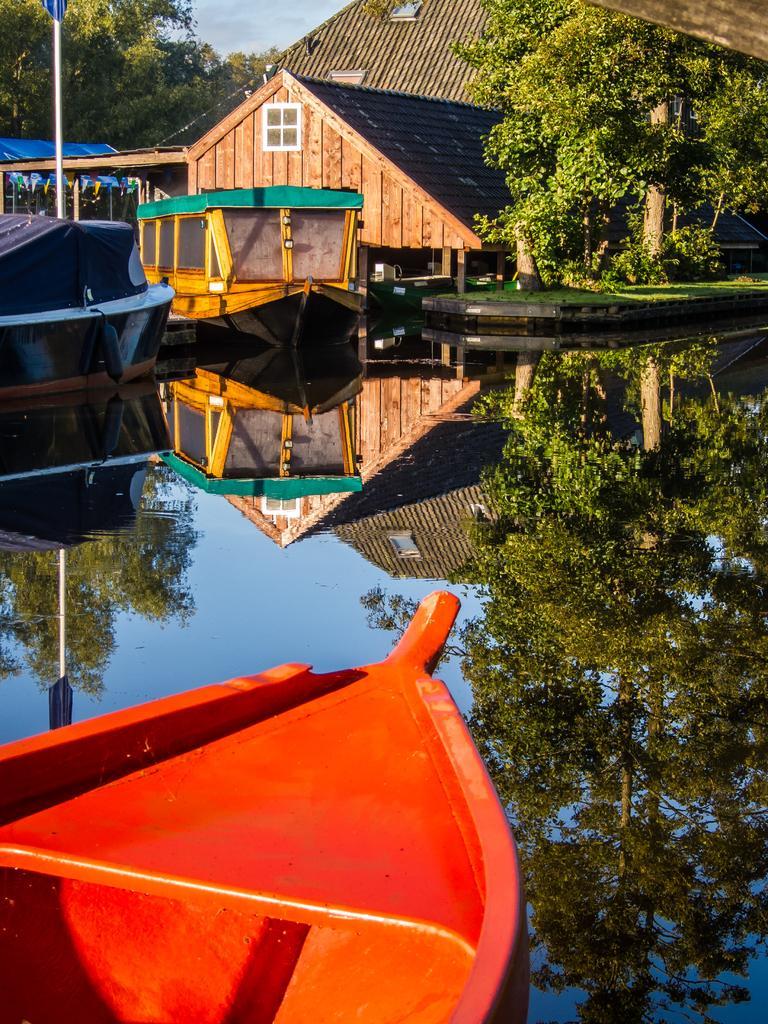Can you describe this image briefly? In this image we can see boats on the water, buildings, poles, trees and sky with clouds. 